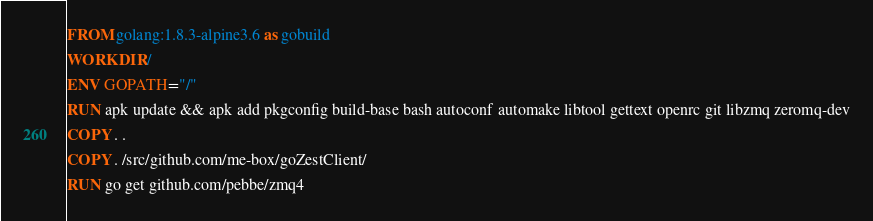Convert code to text. <code><loc_0><loc_0><loc_500><loc_500><_Dockerfile_>FROM golang:1.8.3-alpine3.6 as gobuild
WORKDIR /
ENV GOPATH="/"
RUN apk update && apk add pkgconfig build-base bash autoconf automake libtool gettext openrc git libzmq zeromq-dev
COPY . .
COPY . /src/github.com/me-box/goZestClient/
RUN go get github.com/pebbe/zmq4</code> 